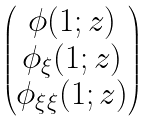<formula> <loc_0><loc_0><loc_500><loc_500>\begin{pmatrix} \phi ( 1 ; z ) \\ \phi _ { \xi } ( 1 ; z ) \\ \phi _ { \xi \xi } ( 1 ; z ) \end{pmatrix}</formula> 